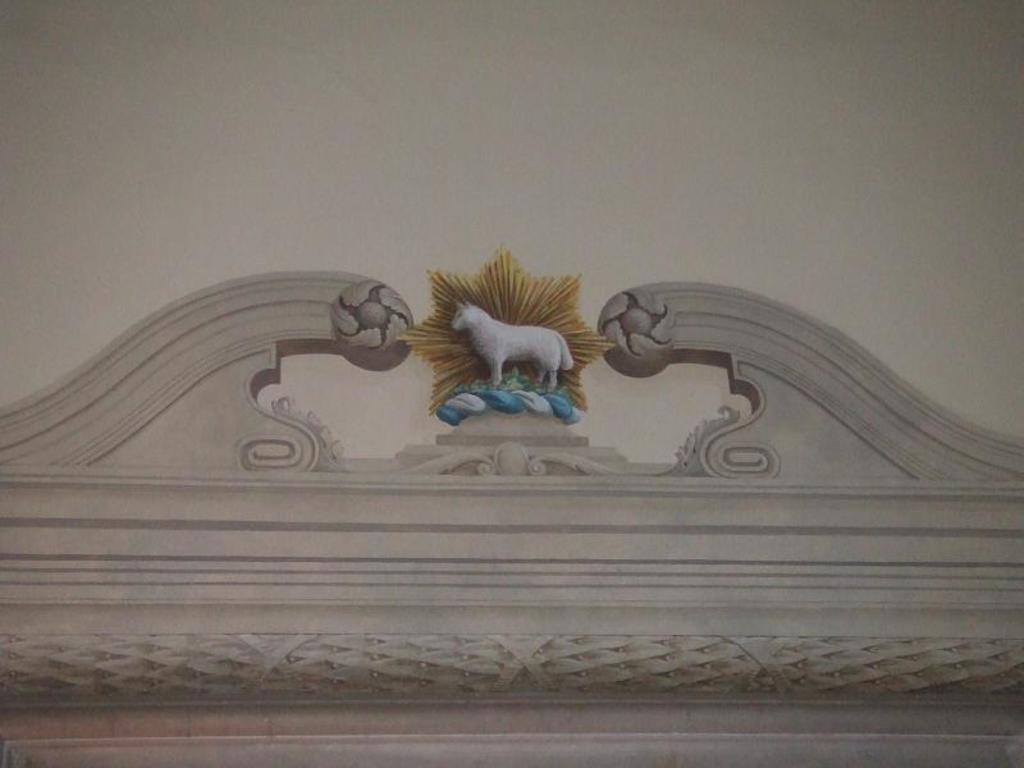What type of object is the main subject in the image? There is an animal statue in the image. What color is the animal statue? The animal statue is white in color. What other element can be seen in the image? There is a wall in the image. What color is the wall? The wall is cream in color. Where is the mom in the image? There is no mom present in the image; it features an animal statue and a wall. How many cats are sitting on the animal statue in the image? There are no cats present in the image; it only features an animal statue and a wall. 